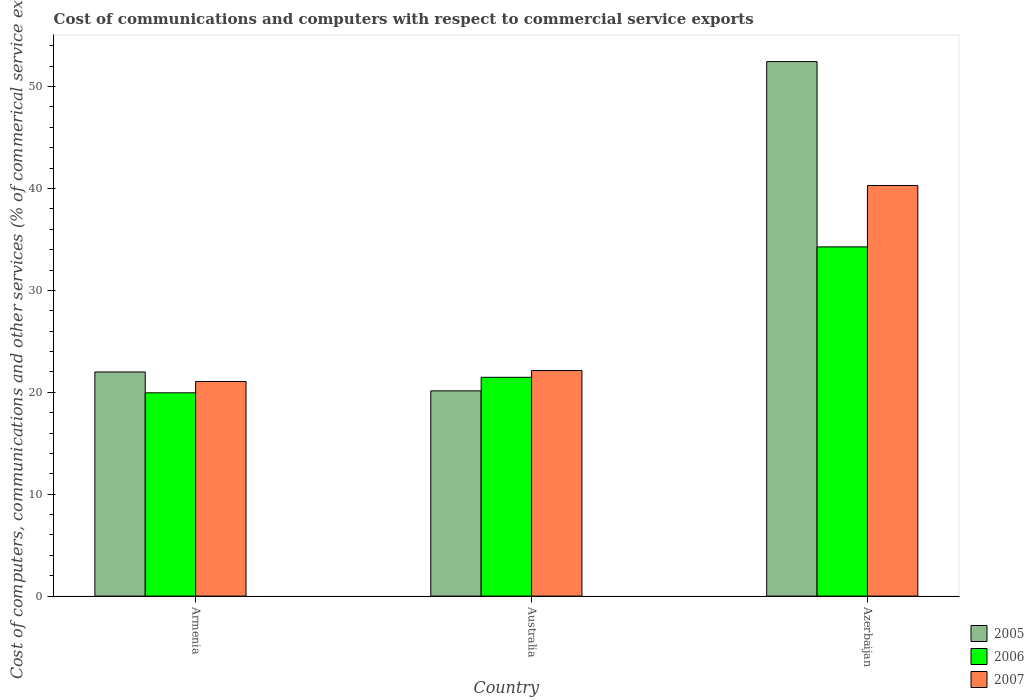How many different coloured bars are there?
Offer a very short reply. 3. How many groups of bars are there?
Keep it short and to the point. 3. How many bars are there on the 1st tick from the left?
Provide a succinct answer. 3. How many bars are there on the 3rd tick from the right?
Provide a succinct answer. 3. What is the label of the 2nd group of bars from the left?
Your answer should be compact. Australia. In how many cases, is the number of bars for a given country not equal to the number of legend labels?
Your answer should be compact. 0. What is the cost of communications and computers in 2006 in Azerbaijan?
Your answer should be compact. 34.27. Across all countries, what is the maximum cost of communications and computers in 2007?
Provide a succinct answer. 40.29. Across all countries, what is the minimum cost of communications and computers in 2007?
Your answer should be compact. 21.06. In which country was the cost of communications and computers in 2005 maximum?
Keep it short and to the point. Azerbaijan. In which country was the cost of communications and computers in 2006 minimum?
Keep it short and to the point. Armenia. What is the total cost of communications and computers in 2005 in the graph?
Offer a very short reply. 94.59. What is the difference between the cost of communications and computers in 2006 in Armenia and that in Azerbaijan?
Provide a short and direct response. -14.32. What is the difference between the cost of communications and computers in 2007 in Armenia and the cost of communications and computers in 2006 in Azerbaijan?
Offer a terse response. -13.21. What is the average cost of communications and computers in 2005 per country?
Give a very brief answer. 31.53. What is the difference between the cost of communications and computers of/in 2006 and cost of communications and computers of/in 2007 in Azerbaijan?
Give a very brief answer. -6.02. What is the ratio of the cost of communications and computers in 2006 in Armenia to that in Azerbaijan?
Make the answer very short. 0.58. What is the difference between the highest and the second highest cost of communications and computers in 2006?
Keep it short and to the point. 14.32. What is the difference between the highest and the lowest cost of communications and computers in 2007?
Your response must be concise. 19.23. In how many countries, is the cost of communications and computers in 2006 greater than the average cost of communications and computers in 2006 taken over all countries?
Offer a very short reply. 1. Is the sum of the cost of communications and computers in 2006 in Armenia and Australia greater than the maximum cost of communications and computers in 2007 across all countries?
Ensure brevity in your answer.  Yes. What does the 1st bar from the right in Australia represents?
Provide a succinct answer. 2007. How many bars are there?
Keep it short and to the point. 9. How many countries are there in the graph?
Provide a short and direct response. 3. What is the difference between two consecutive major ticks on the Y-axis?
Give a very brief answer. 10. Where does the legend appear in the graph?
Keep it short and to the point. Bottom right. How many legend labels are there?
Give a very brief answer. 3. What is the title of the graph?
Your answer should be compact. Cost of communications and computers with respect to commercial service exports. Does "2001" appear as one of the legend labels in the graph?
Keep it short and to the point. No. What is the label or title of the X-axis?
Ensure brevity in your answer.  Country. What is the label or title of the Y-axis?
Provide a short and direct response. Cost of computers, communications and other services (% of commerical service exports). What is the Cost of computers, communications and other services (% of commerical service exports) of 2005 in Armenia?
Your answer should be compact. 22. What is the Cost of computers, communications and other services (% of commerical service exports) of 2006 in Armenia?
Provide a succinct answer. 19.95. What is the Cost of computers, communications and other services (% of commerical service exports) of 2007 in Armenia?
Provide a short and direct response. 21.06. What is the Cost of computers, communications and other services (% of commerical service exports) of 2005 in Australia?
Provide a short and direct response. 20.14. What is the Cost of computers, communications and other services (% of commerical service exports) of 2006 in Australia?
Offer a terse response. 21.47. What is the Cost of computers, communications and other services (% of commerical service exports) in 2007 in Australia?
Your response must be concise. 22.14. What is the Cost of computers, communications and other services (% of commerical service exports) in 2005 in Azerbaijan?
Offer a very short reply. 52.45. What is the Cost of computers, communications and other services (% of commerical service exports) in 2006 in Azerbaijan?
Your response must be concise. 34.27. What is the Cost of computers, communications and other services (% of commerical service exports) of 2007 in Azerbaijan?
Keep it short and to the point. 40.29. Across all countries, what is the maximum Cost of computers, communications and other services (% of commerical service exports) in 2005?
Your answer should be compact. 52.45. Across all countries, what is the maximum Cost of computers, communications and other services (% of commerical service exports) in 2006?
Ensure brevity in your answer.  34.27. Across all countries, what is the maximum Cost of computers, communications and other services (% of commerical service exports) in 2007?
Offer a very short reply. 40.29. Across all countries, what is the minimum Cost of computers, communications and other services (% of commerical service exports) in 2005?
Offer a very short reply. 20.14. Across all countries, what is the minimum Cost of computers, communications and other services (% of commerical service exports) in 2006?
Make the answer very short. 19.95. Across all countries, what is the minimum Cost of computers, communications and other services (% of commerical service exports) of 2007?
Your answer should be very brief. 21.06. What is the total Cost of computers, communications and other services (% of commerical service exports) of 2005 in the graph?
Offer a very short reply. 94.59. What is the total Cost of computers, communications and other services (% of commerical service exports) of 2006 in the graph?
Provide a short and direct response. 75.69. What is the total Cost of computers, communications and other services (% of commerical service exports) in 2007 in the graph?
Your response must be concise. 83.49. What is the difference between the Cost of computers, communications and other services (% of commerical service exports) in 2005 in Armenia and that in Australia?
Make the answer very short. 1.85. What is the difference between the Cost of computers, communications and other services (% of commerical service exports) in 2006 in Armenia and that in Australia?
Offer a very short reply. -1.52. What is the difference between the Cost of computers, communications and other services (% of commerical service exports) in 2007 in Armenia and that in Australia?
Make the answer very short. -1.08. What is the difference between the Cost of computers, communications and other services (% of commerical service exports) of 2005 in Armenia and that in Azerbaijan?
Your answer should be compact. -30.46. What is the difference between the Cost of computers, communications and other services (% of commerical service exports) in 2006 in Armenia and that in Azerbaijan?
Your answer should be very brief. -14.32. What is the difference between the Cost of computers, communications and other services (% of commerical service exports) in 2007 in Armenia and that in Azerbaijan?
Your answer should be very brief. -19.23. What is the difference between the Cost of computers, communications and other services (% of commerical service exports) of 2005 in Australia and that in Azerbaijan?
Your answer should be compact. -32.31. What is the difference between the Cost of computers, communications and other services (% of commerical service exports) of 2006 in Australia and that in Azerbaijan?
Provide a short and direct response. -12.8. What is the difference between the Cost of computers, communications and other services (% of commerical service exports) in 2007 in Australia and that in Azerbaijan?
Provide a short and direct response. -18.16. What is the difference between the Cost of computers, communications and other services (% of commerical service exports) in 2005 in Armenia and the Cost of computers, communications and other services (% of commerical service exports) in 2006 in Australia?
Give a very brief answer. 0.52. What is the difference between the Cost of computers, communications and other services (% of commerical service exports) of 2005 in Armenia and the Cost of computers, communications and other services (% of commerical service exports) of 2007 in Australia?
Your response must be concise. -0.14. What is the difference between the Cost of computers, communications and other services (% of commerical service exports) in 2006 in Armenia and the Cost of computers, communications and other services (% of commerical service exports) in 2007 in Australia?
Your response must be concise. -2.19. What is the difference between the Cost of computers, communications and other services (% of commerical service exports) of 2005 in Armenia and the Cost of computers, communications and other services (% of commerical service exports) of 2006 in Azerbaijan?
Provide a succinct answer. -12.27. What is the difference between the Cost of computers, communications and other services (% of commerical service exports) in 2005 in Armenia and the Cost of computers, communications and other services (% of commerical service exports) in 2007 in Azerbaijan?
Offer a terse response. -18.3. What is the difference between the Cost of computers, communications and other services (% of commerical service exports) in 2006 in Armenia and the Cost of computers, communications and other services (% of commerical service exports) in 2007 in Azerbaijan?
Provide a short and direct response. -20.34. What is the difference between the Cost of computers, communications and other services (% of commerical service exports) of 2005 in Australia and the Cost of computers, communications and other services (% of commerical service exports) of 2006 in Azerbaijan?
Ensure brevity in your answer.  -14.13. What is the difference between the Cost of computers, communications and other services (% of commerical service exports) of 2005 in Australia and the Cost of computers, communications and other services (% of commerical service exports) of 2007 in Azerbaijan?
Offer a terse response. -20.15. What is the difference between the Cost of computers, communications and other services (% of commerical service exports) of 2006 in Australia and the Cost of computers, communications and other services (% of commerical service exports) of 2007 in Azerbaijan?
Make the answer very short. -18.82. What is the average Cost of computers, communications and other services (% of commerical service exports) in 2005 per country?
Your response must be concise. 31.53. What is the average Cost of computers, communications and other services (% of commerical service exports) of 2006 per country?
Provide a succinct answer. 25.23. What is the average Cost of computers, communications and other services (% of commerical service exports) in 2007 per country?
Provide a short and direct response. 27.83. What is the difference between the Cost of computers, communications and other services (% of commerical service exports) in 2005 and Cost of computers, communications and other services (% of commerical service exports) in 2006 in Armenia?
Make the answer very short. 2.05. What is the difference between the Cost of computers, communications and other services (% of commerical service exports) of 2005 and Cost of computers, communications and other services (% of commerical service exports) of 2007 in Armenia?
Your answer should be very brief. 0.94. What is the difference between the Cost of computers, communications and other services (% of commerical service exports) in 2006 and Cost of computers, communications and other services (% of commerical service exports) in 2007 in Armenia?
Offer a very short reply. -1.11. What is the difference between the Cost of computers, communications and other services (% of commerical service exports) of 2005 and Cost of computers, communications and other services (% of commerical service exports) of 2006 in Australia?
Ensure brevity in your answer.  -1.33. What is the difference between the Cost of computers, communications and other services (% of commerical service exports) of 2005 and Cost of computers, communications and other services (% of commerical service exports) of 2007 in Australia?
Make the answer very short. -1.99. What is the difference between the Cost of computers, communications and other services (% of commerical service exports) in 2006 and Cost of computers, communications and other services (% of commerical service exports) in 2007 in Australia?
Offer a very short reply. -0.66. What is the difference between the Cost of computers, communications and other services (% of commerical service exports) in 2005 and Cost of computers, communications and other services (% of commerical service exports) in 2006 in Azerbaijan?
Your response must be concise. 18.19. What is the difference between the Cost of computers, communications and other services (% of commerical service exports) in 2005 and Cost of computers, communications and other services (% of commerical service exports) in 2007 in Azerbaijan?
Give a very brief answer. 12.16. What is the difference between the Cost of computers, communications and other services (% of commerical service exports) of 2006 and Cost of computers, communications and other services (% of commerical service exports) of 2007 in Azerbaijan?
Your response must be concise. -6.02. What is the ratio of the Cost of computers, communications and other services (% of commerical service exports) in 2005 in Armenia to that in Australia?
Provide a short and direct response. 1.09. What is the ratio of the Cost of computers, communications and other services (% of commerical service exports) of 2006 in Armenia to that in Australia?
Offer a terse response. 0.93. What is the ratio of the Cost of computers, communications and other services (% of commerical service exports) in 2007 in Armenia to that in Australia?
Give a very brief answer. 0.95. What is the ratio of the Cost of computers, communications and other services (% of commerical service exports) in 2005 in Armenia to that in Azerbaijan?
Make the answer very short. 0.42. What is the ratio of the Cost of computers, communications and other services (% of commerical service exports) of 2006 in Armenia to that in Azerbaijan?
Your answer should be compact. 0.58. What is the ratio of the Cost of computers, communications and other services (% of commerical service exports) in 2007 in Armenia to that in Azerbaijan?
Make the answer very short. 0.52. What is the ratio of the Cost of computers, communications and other services (% of commerical service exports) in 2005 in Australia to that in Azerbaijan?
Ensure brevity in your answer.  0.38. What is the ratio of the Cost of computers, communications and other services (% of commerical service exports) in 2006 in Australia to that in Azerbaijan?
Your answer should be very brief. 0.63. What is the ratio of the Cost of computers, communications and other services (% of commerical service exports) in 2007 in Australia to that in Azerbaijan?
Your answer should be compact. 0.55. What is the difference between the highest and the second highest Cost of computers, communications and other services (% of commerical service exports) in 2005?
Give a very brief answer. 30.46. What is the difference between the highest and the second highest Cost of computers, communications and other services (% of commerical service exports) of 2006?
Your response must be concise. 12.8. What is the difference between the highest and the second highest Cost of computers, communications and other services (% of commerical service exports) of 2007?
Keep it short and to the point. 18.16. What is the difference between the highest and the lowest Cost of computers, communications and other services (% of commerical service exports) in 2005?
Make the answer very short. 32.31. What is the difference between the highest and the lowest Cost of computers, communications and other services (% of commerical service exports) in 2006?
Provide a succinct answer. 14.32. What is the difference between the highest and the lowest Cost of computers, communications and other services (% of commerical service exports) in 2007?
Ensure brevity in your answer.  19.23. 